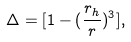<formula> <loc_0><loc_0><loc_500><loc_500>\Delta = [ 1 - ( \frac { r _ { h } } { r } ) ^ { 3 } ] ,</formula> 